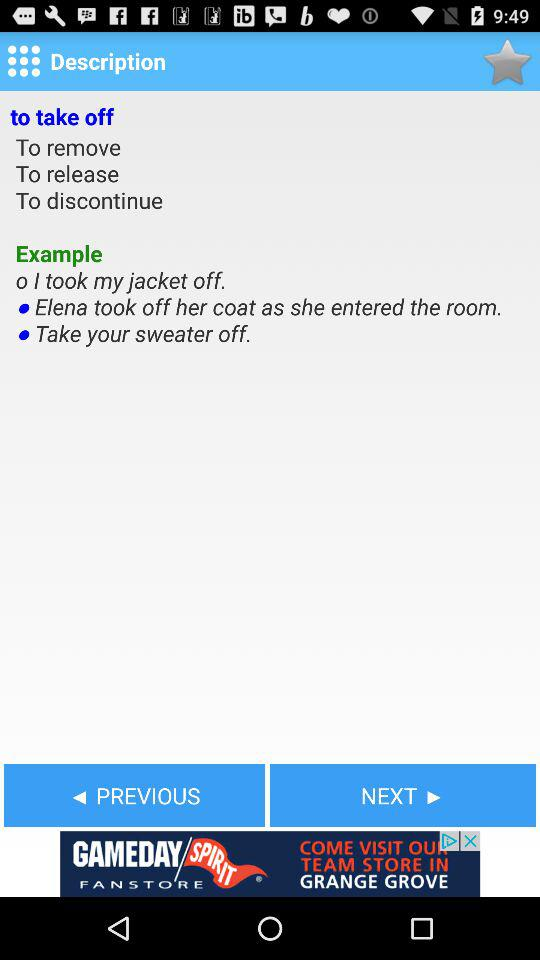How many examples are there?
Answer the question using a single word or phrase. 3 